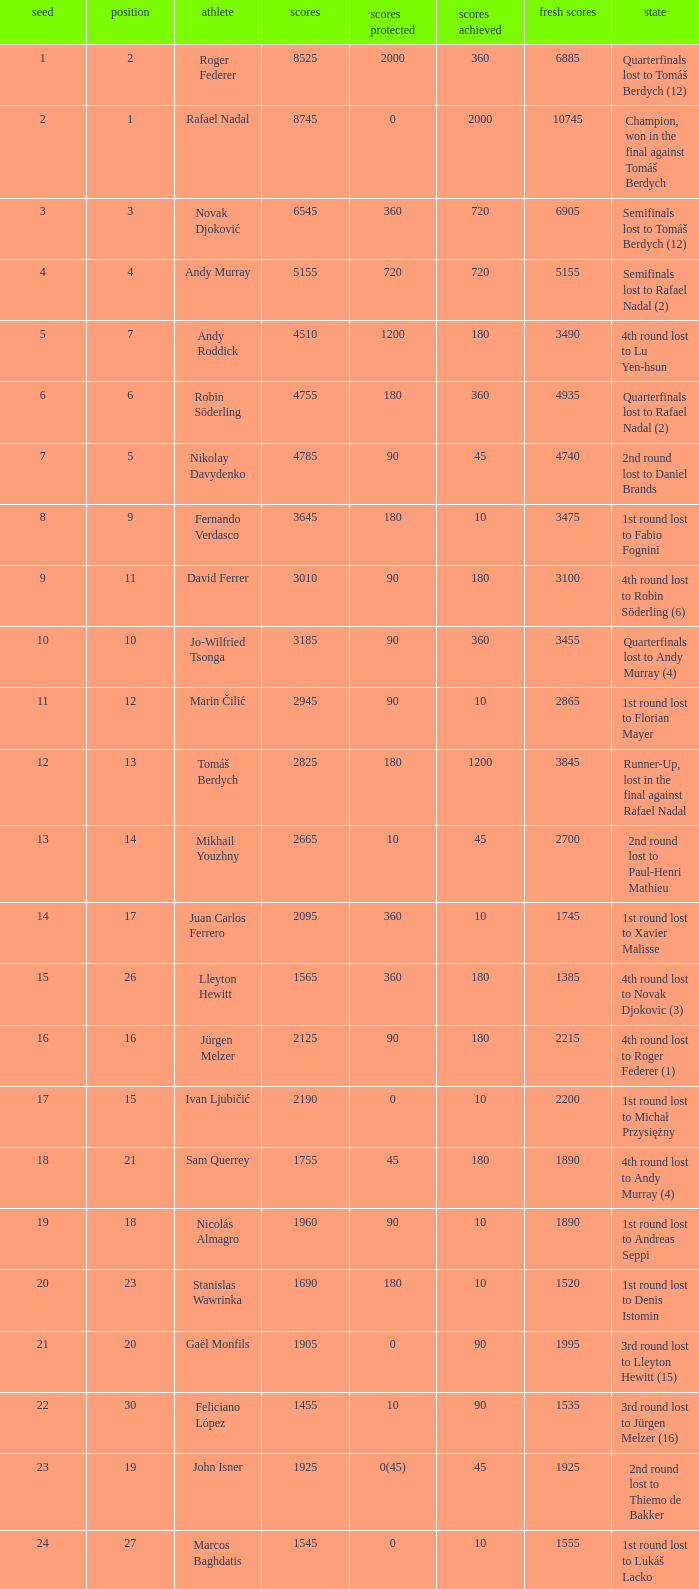Name the least new points for points defending is 1200 3490.0. 